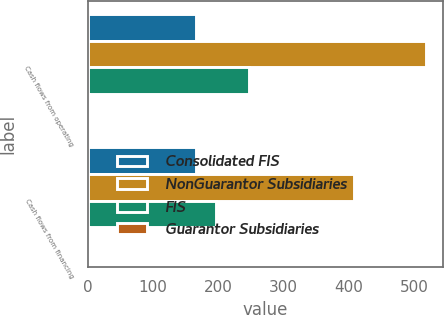Convert chart. <chart><loc_0><loc_0><loc_500><loc_500><stacked_bar_chart><ecel><fcel>Cash flows from operating<fcel>Cash flows from financing<nl><fcel>Consolidated FIS<fcel>166.4<fcel>165.5<nl><fcel>NonGuarantor Subsidiaries<fcel>517.6<fcel>408.6<nl><fcel>FIS<fcel>246.7<fcel>196.8<nl><fcel>Guarantor Subsidiaries<fcel>1.5<fcel>1.5<nl></chart> 